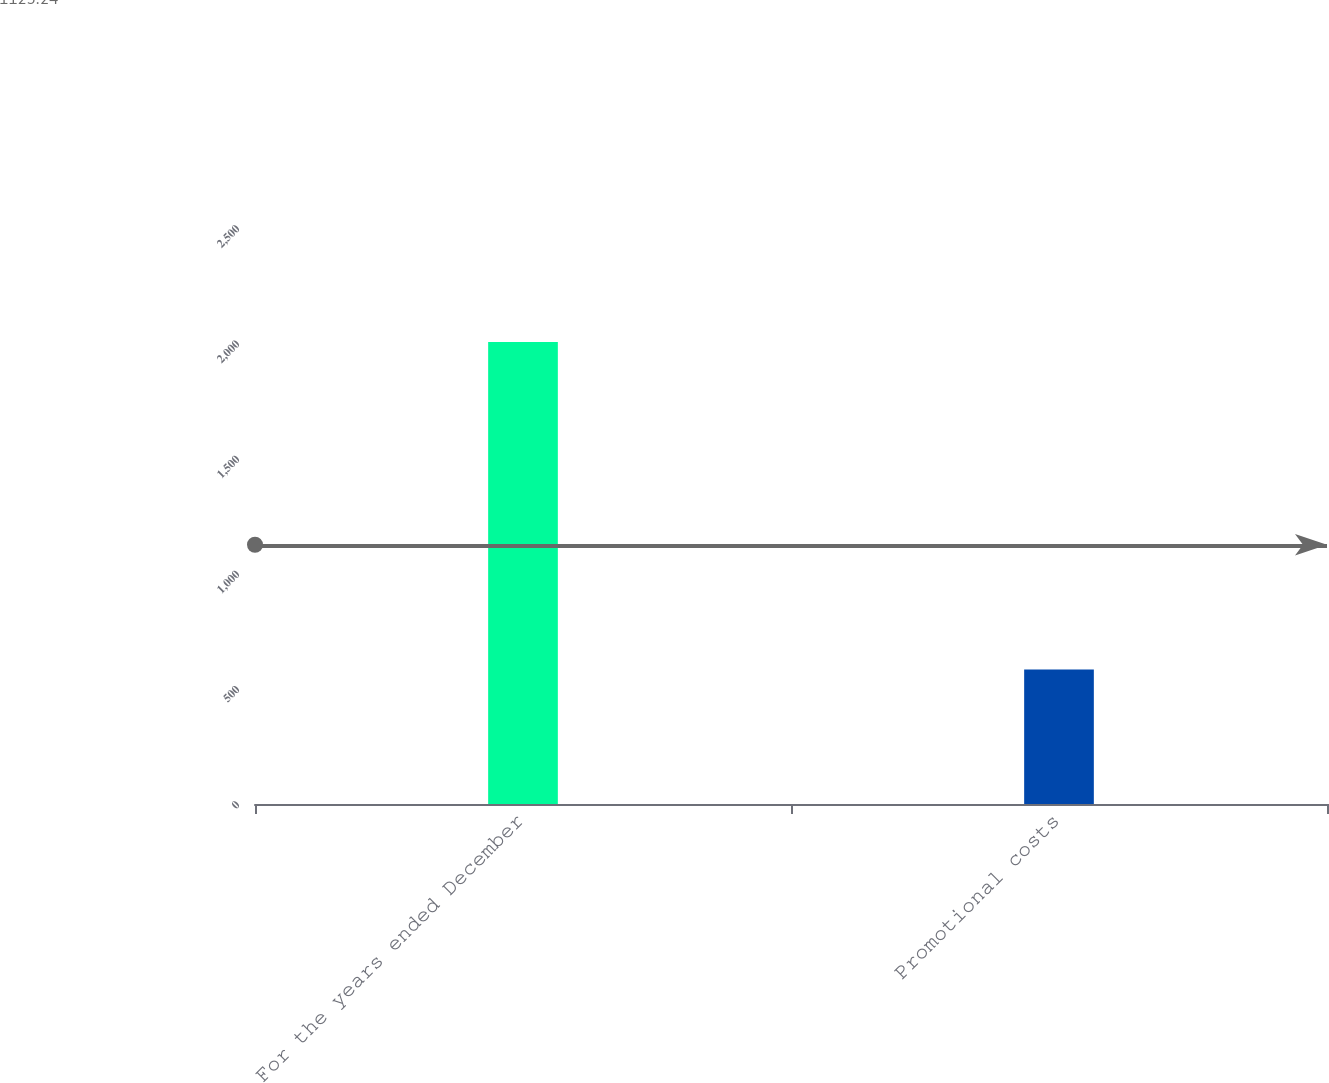Convert chart. <chart><loc_0><loc_0><loc_500><loc_500><bar_chart><fcel>For the years ended December<fcel>Promotional costs<nl><fcel>2005<fcel>583.5<nl></chart> 